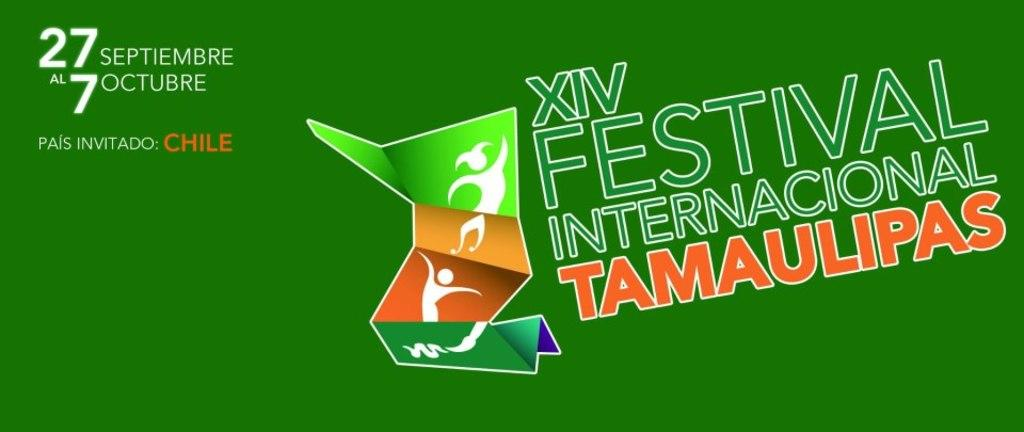<image>
Render a clear and concise summary of the photo. Green poster showing a festival takes place on the 27th. 